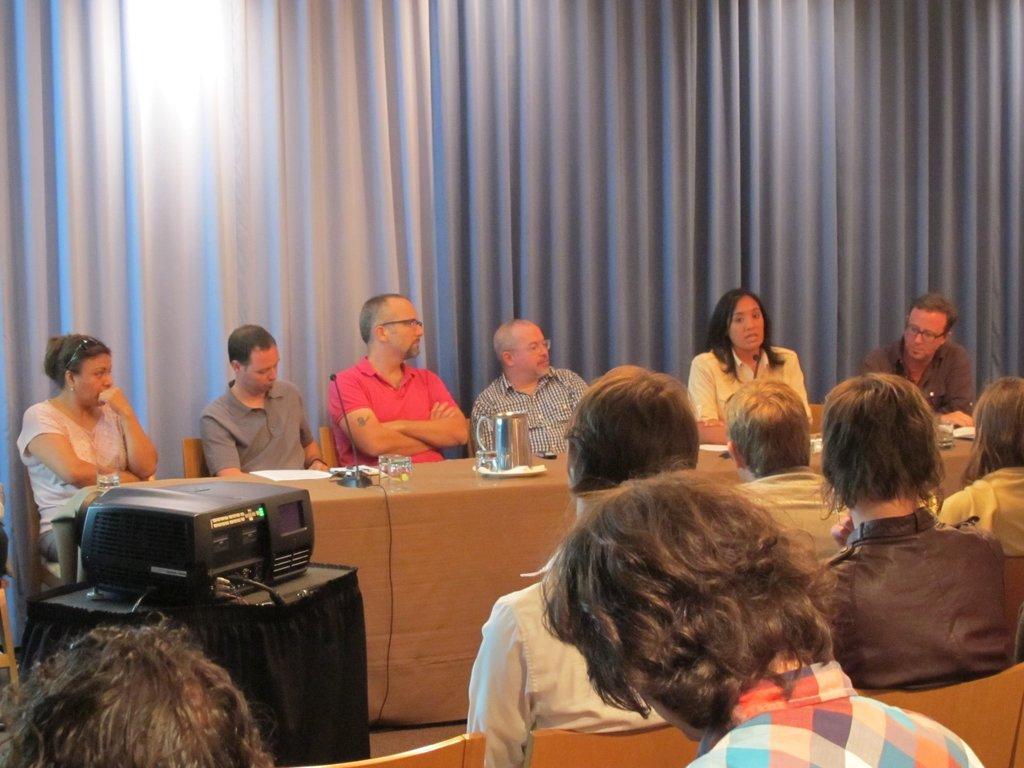Can you describe this image briefly? As we can see in the image there are curtains, few people sitting on chairs, a projector and a table. On table there is a mug and plate. 